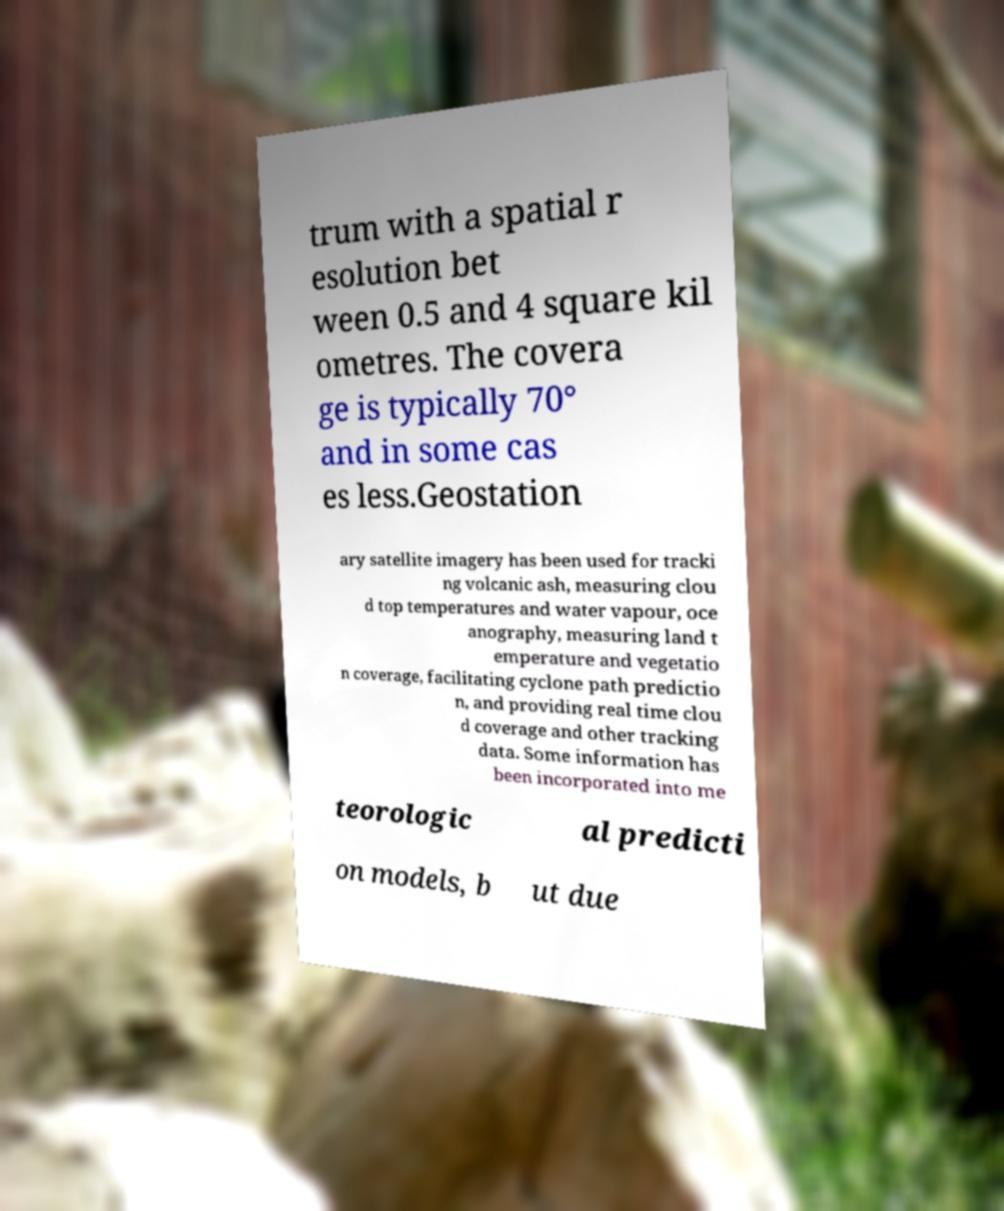I need the written content from this picture converted into text. Can you do that? trum with a spatial r esolution bet ween 0.5 and 4 square kil ometres. The covera ge is typically 70° and in some cas es less.Geostation ary satellite imagery has been used for tracki ng volcanic ash, measuring clou d top temperatures and water vapour, oce anography, measuring land t emperature and vegetatio n coverage, facilitating cyclone path predictio n, and providing real time clou d coverage and other tracking data. Some information has been incorporated into me teorologic al predicti on models, b ut due 